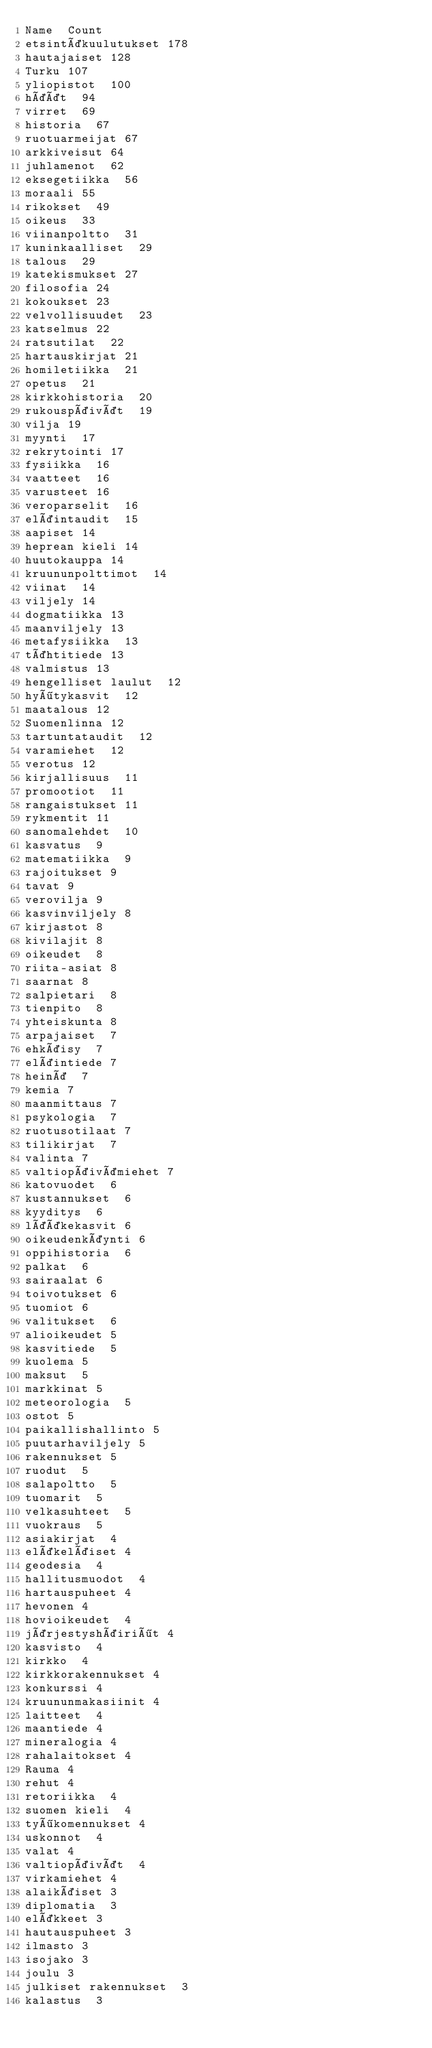<code> <loc_0><loc_0><loc_500><loc_500><_SQL_>Name	Count
etsintäkuulutukset	178
hautajaiset	128
Turku	107
yliopistot	100
häät	94
virret	69
historia	67
ruotuarmeijat	67
arkkiveisut	64
juhlamenot	62
eksegetiikka	56
moraali	55
rikokset	49
oikeus	33
viinanpoltto	31
kuninkaalliset	29
talous	29
katekismukset	27
filosofia	24
kokoukset	23
velvollisuudet	23
katselmus	22
ratsutilat	22
hartauskirjat	21
homiletiikka	21
opetus	21
kirkkohistoria	20
rukouspäivät	19
vilja	19
myynti	17
rekrytointi	17
fysiikka	16
vaatteet	16
varusteet	16
veroparselit	16
eläintaudit	15
aapiset	14
heprean kieli	14
huutokauppa	14
kruununpolttimot	14
viinat	14
viljely	14
dogmatiikka	13
maanviljely	13
metafysiikka	13
tähtitiede	13
valmistus	13
hengelliset laulut	12
hyötykasvit	12
maatalous	12
Suomenlinna	12
tartuntataudit	12
varamiehet	12
verotus	12
kirjallisuus	11
promootiot	11
rangaistukset	11
rykmentit	11
sanomalehdet	10
kasvatus	9
matematiikka	9
rajoitukset	9
tavat	9
verovilja	9
kasvinviljely	8
kirjastot	8
kivilajit	8
oikeudet	8
riita-asiat	8
saarnat	8
salpietari	8
tienpito	8
yhteiskunta	8
arpajaiset	7
ehkäisy	7
eläintiede	7
heinä	7
kemia	7
maanmittaus	7
psykologia	7
ruotusotilaat	7
tilikirjat	7
valinta	7
valtiopäivämiehet	7
katovuodet	6
kustannukset	6
kyyditys	6
lääkekasvit	6
oikeudenkäynti	6
oppihistoria	6
palkat	6
sairaalat	6
toivotukset	6
tuomiot	6
valitukset	6
alioikeudet	5
kasvitiede	5
kuolema	5
maksut	5
markkinat	5
meteorologia	5
ostot	5
paikallishallinto	5
puutarhaviljely	5
rakennukset	5
ruodut	5
salapoltto	5
tuomarit	5
velkasuhteet	5
vuokraus	5
asiakirjat	4
eläkeläiset	4
geodesia	4
hallitusmuodot	4
hartauspuheet	4
hevonen	4
hovioikeudet	4
järjestyshäiriöt	4
kasvisto	4
kirkko	4
kirkkorakennukset	4
konkurssi	4
kruununmakasiinit	4
laitteet	4
maantiede	4
mineralogia	4
rahalaitokset	4
Rauma	4
rehut	4
retoriikka	4
suomen kieli	4
työkomennukset	4
uskonnot	4
valat	4
valtiopäivät	4
virkamiehet	4
alaikäiset	3
diplomatia	3
eläkkeet	3
hautauspuheet	3
ilmasto	3
isojako	3
joulu	3
julkiset rakennukset	3
kalastus	3</code> 